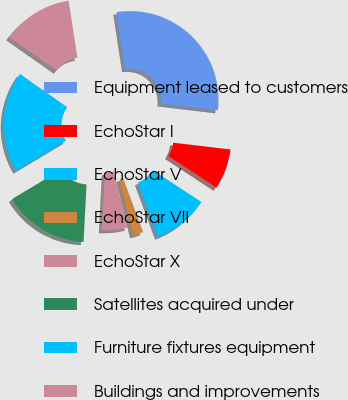Convert chart. <chart><loc_0><loc_0><loc_500><loc_500><pie_chart><fcel>Equipment leased to customers<fcel>EchoStar I<fcel>EchoStar V<fcel>EchoStar VII<fcel>EchoStar X<fcel>Satellites acquired under<fcel>Furniture fixtures equipment<fcel>Buildings and improvements<nl><fcel>29.3%<fcel>7.36%<fcel>10.1%<fcel>1.87%<fcel>4.61%<fcel>15.59%<fcel>18.33%<fcel>12.84%<nl></chart> 